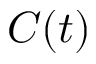<formula> <loc_0><loc_0><loc_500><loc_500>C ( t )</formula> 